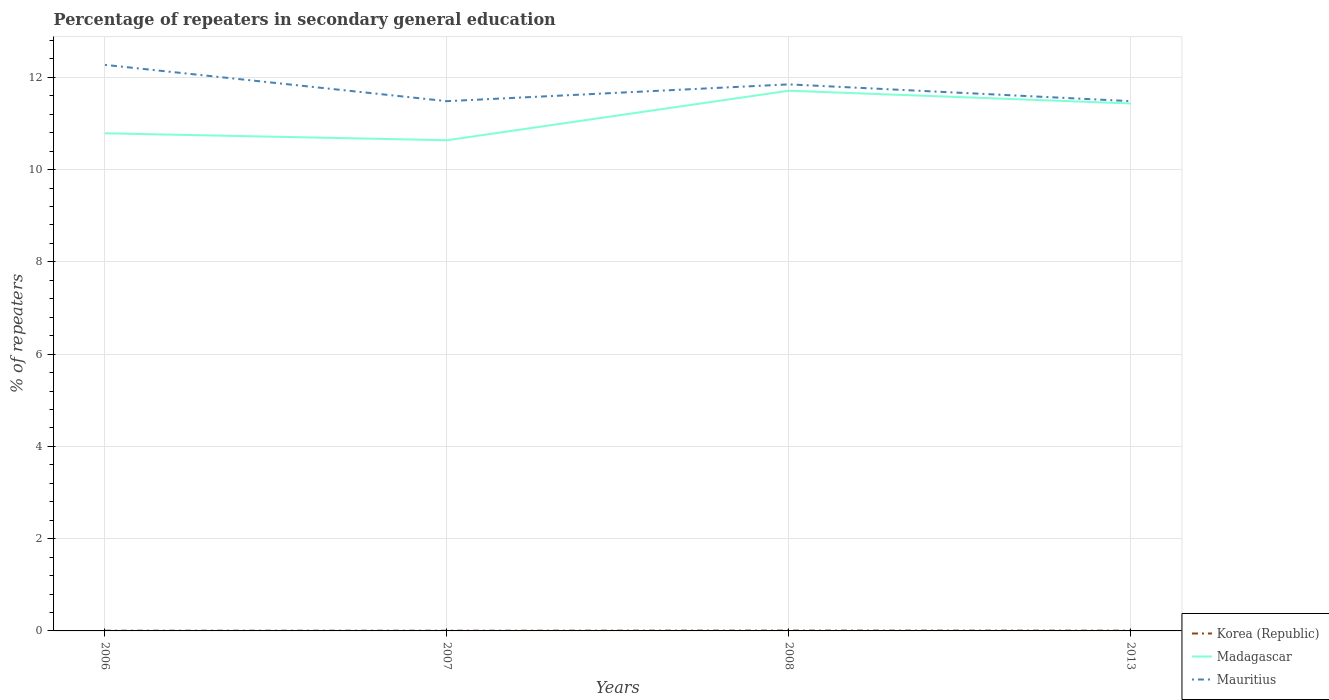Does the line corresponding to Mauritius intersect with the line corresponding to Madagascar?
Offer a terse response. No. Is the number of lines equal to the number of legend labels?
Make the answer very short. Yes. Across all years, what is the maximum percentage of repeaters in secondary general education in Mauritius?
Keep it short and to the point. 11.48. What is the total percentage of repeaters in secondary general education in Korea (Republic) in the graph?
Offer a terse response. -4.9999915063389e-5. What is the difference between the highest and the second highest percentage of repeaters in secondary general education in Mauritius?
Provide a short and direct response. 0.79. Is the percentage of repeaters in secondary general education in Korea (Republic) strictly greater than the percentage of repeaters in secondary general education in Madagascar over the years?
Offer a very short reply. Yes. How many lines are there?
Offer a very short reply. 3. Are the values on the major ticks of Y-axis written in scientific E-notation?
Offer a terse response. No. Does the graph contain grids?
Make the answer very short. Yes. Where does the legend appear in the graph?
Provide a short and direct response. Bottom right. How are the legend labels stacked?
Ensure brevity in your answer.  Vertical. What is the title of the graph?
Keep it short and to the point. Percentage of repeaters in secondary general education. What is the label or title of the Y-axis?
Give a very brief answer. % of repeaters. What is the % of repeaters of Korea (Republic) in 2006?
Keep it short and to the point. 0. What is the % of repeaters in Madagascar in 2006?
Make the answer very short. 10.79. What is the % of repeaters of Mauritius in 2006?
Make the answer very short. 12.27. What is the % of repeaters in Korea (Republic) in 2007?
Keep it short and to the point. 0. What is the % of repeaters of Madagascar in 2007?
Your response must be concise. 10.64. What is the % of repeaters in Mauritius in 2007?
Offer a very short reply. 11.48. What is the % of repeaters of Korea (Republic) in 2008?
Your answer should be very brief. 0.01. What is the % of repeaters in Madagascar in 2008?
Provide a succinct answer. 11.71. What is the % of repeaters of Mauritius in 2008?
Your response must be concise. 11.85. What is the % of repeaters of Korea (Republic) in 2013?
Make the answer very short. 0.01. What is the % of repeaters in Madagascar in 2013?
Keep it short and to the point. 11.43. What is the % of repeaters of Mauritius in 2013?
Provide a short and direct response. 11.48. Across all years, what is the maximum % of repeaters in Korea (Republic)?
Keep it short and to the point. 0.01. Across all years, what is the maximum % of repeaters of Madagascar?
Your answer should be compact. 11.71. Across all years, what is the maximum % of repeaters in Mauritius?
Your answer should be compact. 12.27. Across all years, what is the minimum % of repeaters of Korea (Republic)?
Make the answer very short. 0. Across all years, what is the minimum % of repeaters in Madagascar?
Offer a terse response. 10.64. Across all years, what is the minimum % of repeaters of Mauritius?
Your answer should be compact. 11.48. What is the total % of repeaters of Korea (Republic) in the graph?
Keep it short and to the point. 0.02. What is the total % of repeaters of Madagascar in the graph?
Make the answer very short. 44.57. What is the total % of repeaters in Mauritius in the graph?
Provide a succinct answer. 47.09. What is the difference between the % of repeaters of Madagascar in 2006 and that in 2007?
Your answer should be compact. 0.15. What is the difference between the % of repeaters of Mauritius in 2006 and that in 2007?
Make the answer very short. 0.79. What is the difference between the % of repeaters of Korea (Republic) in 2006 and that in 2008?
Offer a terse response. -0. What is the difference between the % of repeaters in Madagascar in 2006 and that in 2008?
Offer a very short reply. -0.92. What is the difference between the % of repeaters in Mauritius in 2006 and that in 2008?
Your answer should be compact. 0.42. What is the difference between the % of repeaters in Korea (Republic) in 2006 and that in 2013?
Provide a succinct answer. -0. What is the difference between the % of repeaters of Madagascar in 2006 and that in 2013?
Offer a very short reply. -0.65. What is the difference between the % of repeaters of Mauritius in 2006 and that in 2013?
Keep it short and to the point. 0.79. What is the difference between the % of repeaters in Korea (Republic) in 2007 and that in 2008?
Give a very brief answer. -0. What is the difference between the % of repeaters in Madagascar in 2007 and that in 2008?
Make the answer very short. -1.07. What is the difference between the % of repeaters of Mauritius in 2007 and that in 2008?
Offer a very short reply. -0.36. What is the difference between the % of repeaters in Korea (Republic) in 2007 and that in 2013?
Provide a short and direct response. -0. What is the difference between the % of repeaters in Madagascar in 2007 and that in 2013?
Make the answer very short. -0.8. What is the difference between the % of repeaters of Mauritius in 2007 and that in 2013?
Your response must be concise. -0. What is the difference between the % of repeaters in Korea (Republic) in 2008 and that in 2013?
Make the answer very short. 0. What is the difference between the % of repeaters in Madagascar in 2008 and that in 2013?
Offer a terse response. 0.28. What is the difference between the % of repeaters of Mauritius in 2008 and that in 2013?
Your answer should be compact. 0.36. What is the difference between the % of repeaters in Korea (Republic) in 2006 and the % of repeaters in Madagascar in 2007?
Give a very brief answer. -10.63. What is the difference between the % of repeaters of Korea (Republic) in 2006 and the % of repeaters of Mauritius in 2007?
Offer a terse response. -11.48. What is the difference between the % of repeaters of Madagascar in 2006 and the % of repeaters of Mauritius in 2007?
Keep it short and to the point. -0.7. What is the difference between the % of repeaters in Korea (Republic) in 2006 and the % of repeaters in Madagascar in 2008?
Make the answer very short. -11.71. What is the difference between the % of repeaters of Korea (Republic) in 2006 and the % of repeaters of Mauritius in 2008?
Provide a short and direct response. -11.84. What is the difference between the % of repeaters of Madagascar in 2006 and the % of repeaters of Mauritius in 2008?
Your answer should be very brief. -1.06. What is the difference between the % of repeaters of Korea (Republic) in 2006 and the % of repeaters of Madagascar in 2013?
Your answer should be compact. -11.43. What is the difference between the % of repeaters in Korea (Republic) in 2006 and the % of repeaters in Mauritius in 2013?
Keep it short and to the point. -11.48. What is the difference between the % of repeaters in Madagascar in 2006 and the % of repeaters in Mauritius in 2013?
Give a very brief answer. -0.7. What is the difference between the % of repeaters in Korea (Republic) in 2007 and the % of repeaters in Madagascar in 2008?
Provide a short and direct response. -11.71. What is the difference between the % of repeaters of Korea (Republic) in 2007 and the % of repeaters of Mauritius in 2008?
Your answer should be compact. -11.84. What is the difference between the % of repeaters of Madagascar in 2007 and the % of repeaters of Mauritius in 2008?
Your answer should be compact. -1.21. What is the difference between the % of repeaters in Korea (Republic) in 2007 and the % of repeaters in Madagascar in 2013?
Make the answer very short. -11.43. What is the difference between the % of repeaters of Korea (Republic) in 2007 and the % of repeaters of Mauritius in 2013?
Keep it short and to the point. -11.48. What is the difference between the % of repeaters of Madagascar in 2007 and the % of repeaters of Mauritius in 2013?
Keep it short and to the point. -0.85. What is the difference between the % of repeaters of Korea (Republic) in 2008 and the % of repeaters of Madagascar in 2013?
Ensure brevity in your answer.  -11.43. What is the difference between the % of repeaters of Korea (Republic) in 2008 and the % of repeaters of Mauritius in 2013?
Provide a succinct answer. -11.48. What is the difference between the % of repeaters of Madagascar in 2008 and the % of repeaters of Mauritius in 2013?
Provide a short and direct response. 0.23. What is the average % of repeaters of Korea (Republic) per year?
Your answer should be compact. 0.01. What is the average % of repeaters of Madagascar per year?
Your response must be concise. 11.14. What is the average % of repeaters in Mauritius per year?
Offer a terse response. 11.77. In the year 2006, what is the difference between the % of repeaters in Korea (Republic) and % of repeaters in Madagascar?
Offer a very short reply. -10.78. In the year 2006, what is the difference between the % of repeaters in Korea (Republic) and % of repeaters in Mauritius?
Keep it short and to the point. -12.27. In the year 2006, what is the difference between the % of repeaters of Madagascar and % of repeaters of Mauritius?
Your answer should be very brief. -1.48. In the year 2007, what is the difference between the % of repeaters of Korea (Republic) and % of repeaters of Madagascar?
Provide a succinct answer. -10.63. In the year 2007, what is the difference between the % of repeaters in Korea (Republic) and % of repeaters in Mauritius?
Your answer should be compact. -11.48. In the year 2007, what is the difference between the % of repeaters in Madagascar and % of repeaters in Mauritius?
Provide a short and direct response. -0.85. In the year 2008, what is the difference between the % of repeaters of Korea (Republic) and % of repeaters of Madagascar?
Provide a short and direct response. -11.7. In the year 2008, what is the difference between the % of repeaters in Korea (Republic) and % of repeaters in Mauritius?
Your answer should be compact. -11.84. In the year 2008, what is the difference between the % of repeaters of Madagascar and % of repeaters of Mauritius?
Keep it short and to the point. -0.14. In the year 2013, what is the difference between the % of repeaters of Korea (Republic) and % of repeaters of Madagascar?
Make the answer very short. -11.43. In the year 2013, what is the difference between the % of repeaters of Korea (Republic) and % of repeaters of Mauritius?
Your answer should be very brief. -11.48. In the year 2013, what is the difference between the % of repeaters of Madagascar and % of repeaters of Mauritius?
Your answer should be compact. -0.05. What is the ratio of the % of repeaters in Korea (Republic) in 2006 to that in 2007?
Provide a short and direct response. 0.99. What is the ratio of the % of repeaters in Madagascar in 2006 to that in 2007?
Provide a succinct answer. 1.01. What is the ratio of the % of repeaters in Mauritius in 2006 to that in 2007?
Offer a terse response. 1.07. What is the ratio of the % of repeaters of Korea (Republic) in 2006 to that in 2008?
Make the answer very short. 0.57. What is the ratio of the % of repeaters in Madagascar in 2006 to that in 2008?
Give a very brief answer. 0.92. What is the ratio of the % of repeaters of Mauritius in 2006 to that in 2008?
Your answer should be compact. 1.04. What is the ratio of the % of repeaters in Korea (Republic) in 2006 to that in 2013?
Make the answer very short. 0.76. What is the ratio of the % of repeaters in Madagascar in 2006 to that in 2013?
Offer a terse response. 0.94. What is the ratio of the % of repeaters of Mauritius in 2006 to that in 2013?
Provide a short and direct response. 1.07. What is the ratio of the % of repeaters of Korea (Republic) in 2007 to that in 2008?
Make the answer very short. 0.58. What is the ratio of the % of repeaters of Madagascar in 2007 to that in 2008?
Ensure brevity in your answer.  0.91. What is the ratio of the % of repeaters in Mauritius in 2007 to that in 2008?
Provide a succinct answer. 0.97. What is the ratio of the % of repeaters of Korea (Republic) in 2007 to that in 2013?
Make the answer very short. 0.77. What is the ratio of the % of repeaters in Madagascar in 2007 to that in 2013?
Your response must be concise. 0.93. What is the ratio of the % of repeaters in Korea (Republic) in 2008 to that in 2013?
Provide a succinct answer. 1.33. What is the ratio of the % of repeaters of Madagascar in 2008 to that in 2013?
Offer a terse response. 1.02. What is the ratio of the % of repeaters in Mauritius in 2008 to that in 2013?
Your answer should be compact. 1.03. What is the difference between the highest and the second highest % of repeaters in Korea (Republic)?
Your answer should be very brief. 0. What is the difference between the highest and the second highest % of repeaters of Madagascar?
Your response must be concise. 0.28. What is the difference between the highest and the second highest % of repeaters in Mauritius?
Ensure brevity in your answer.  0.42. What is the difference between the highest and the lowest % of repeaters in Korea (Republic)?
Offer a very short reply. 0. What is the difference between the highest and the lowest % of repeaters in Madagascar?
Your answer should be very brief. 1.07. What is the difference between the highest and the lowest % of repeaters of Mauritius?
Offer a terse response. 0.79. 